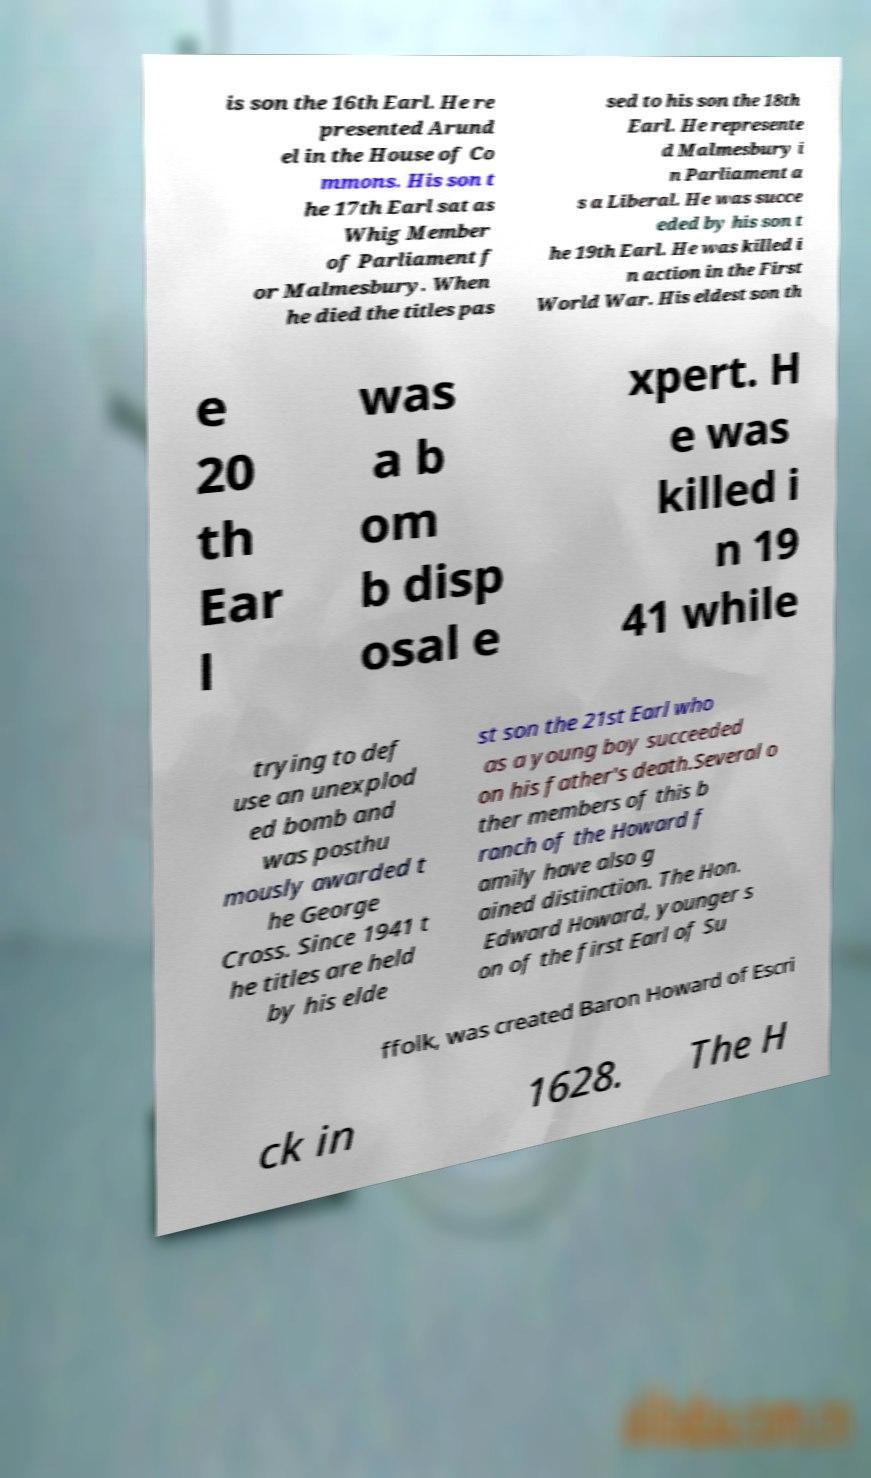I need the written content from this picture converted into text. Can you do that? is son the 16th Earl. He re presented Arund el in the House of Co mmons. His son t he 17th Earl sat as Whig Member of Parliament f or Malmesbury. When he died the titles pas sed to his son the 18th Earl. He represente d Malmesbury i n Parliament a s a Liberal. He was succe eded by his son t he 19th Earl. He was killed i n action in the First World War. His eldest son th e 20 th Ear l was a b om b disp osal e xpert. H e was killed i n 19 41 while trying to def use an unexplod ed bomb and was posthu mously awarded t he George Cross. Since 1941 t he titles are held by his elde st son the 21st Earl who as a young boy succeeded on his father's death.Several o ther members of this b ranch of the Howard f amily have also g ained distinction. The Hon. Edward Howard, younger s on of the first Earl of Su ffolk, was created Baron Howard of Escri ck in 1628. The H 